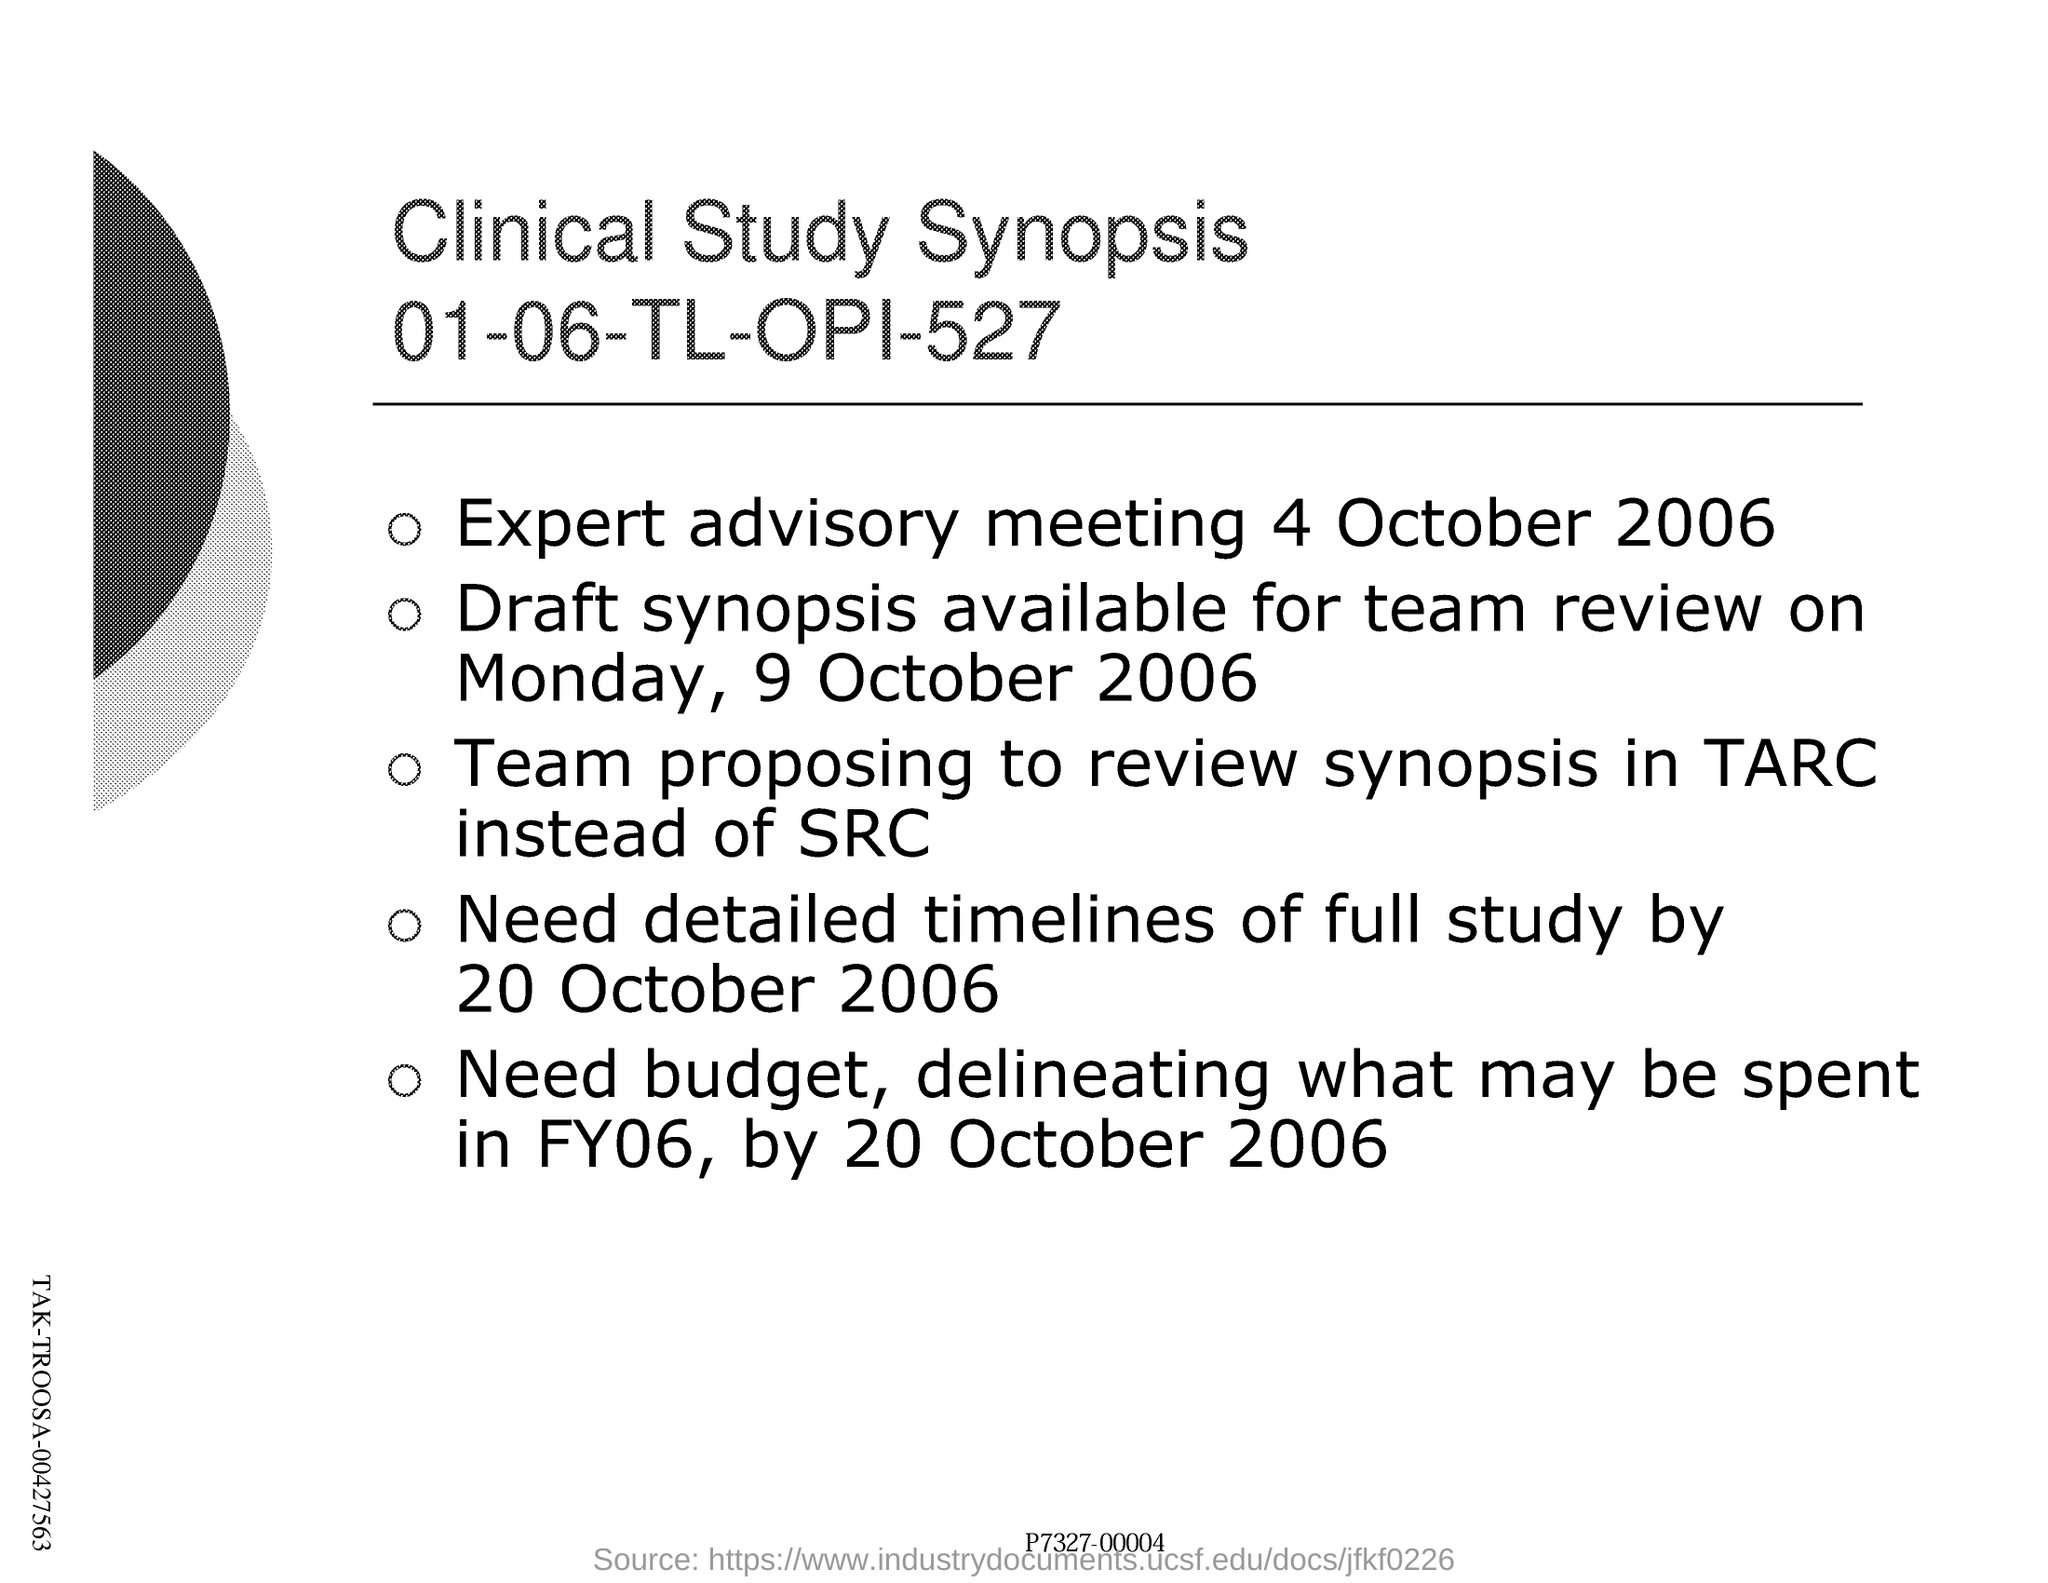Highlight a few significant elements in this photo. This is a summary of a clinical study. The clinical study synopsis refers to a specific code number, 01-06-TL-OPI-527, which provides information about a clinical study that has been conducted or is currently underway. The expert advisory meeting took place on October 4th, 2006. 